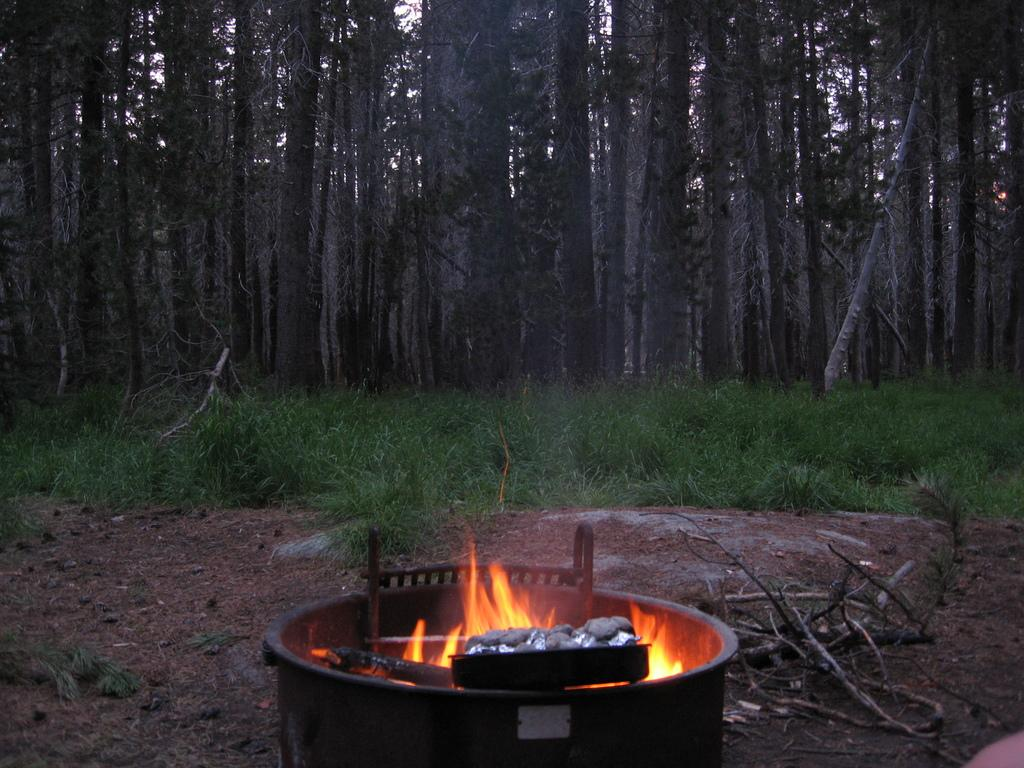What is the main feature in the front of the image? There is a bonfire in the front of the image. What type of vegetation is visible behind the bonfire? There is grass visible behind the bonfire. What can be seen in the background of the image? There are many huge trees in the background of the image. What type of alarm is ringing in the image? There is no alarm present in the image. How much debt is visible in the image? There is no reference to debt in the image. 